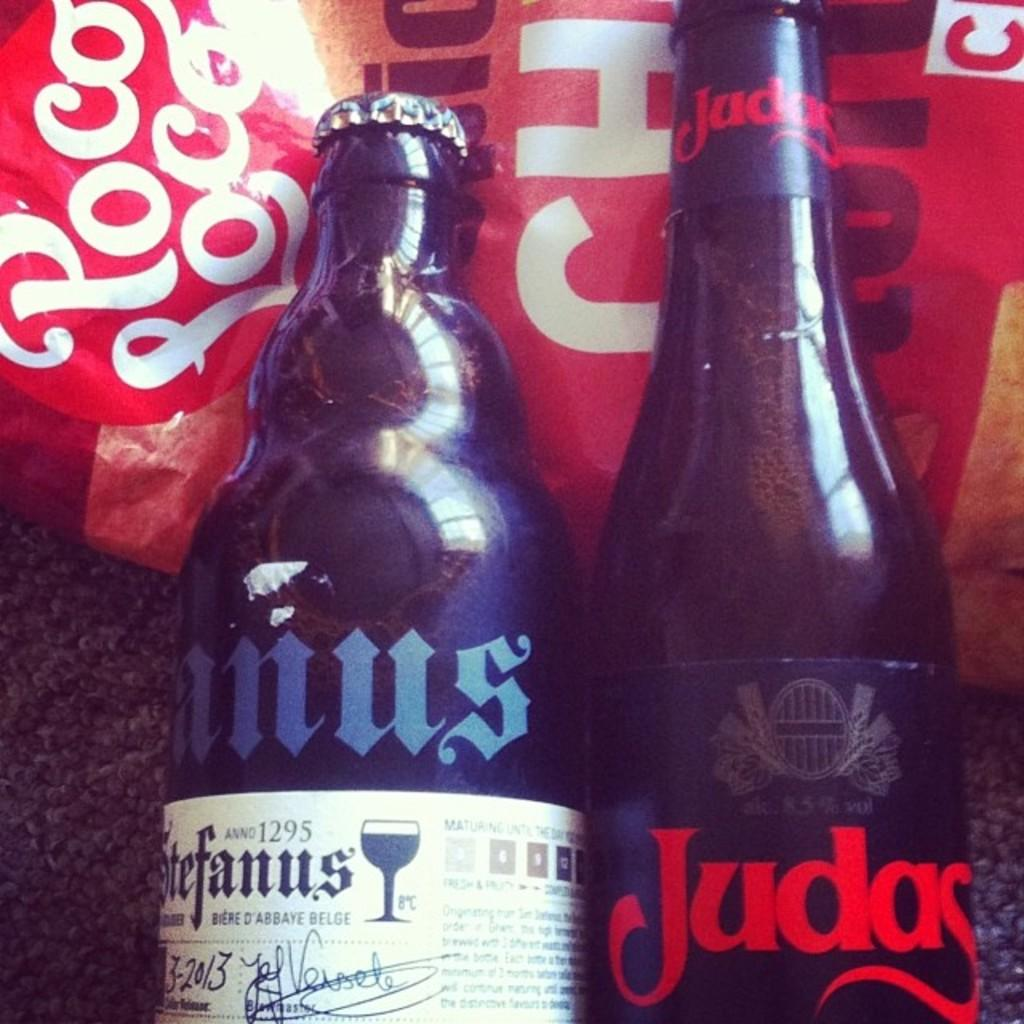What object can be seen in the image? There is a bottle in the image. What is on the bottle? The bottle has a sticker. What is covering the opening of the bottle? The bottle has a cap. Where is the flower located in the image? There is no flower present in the image. What type of street is visible in the image? There is no street visible in the image. 